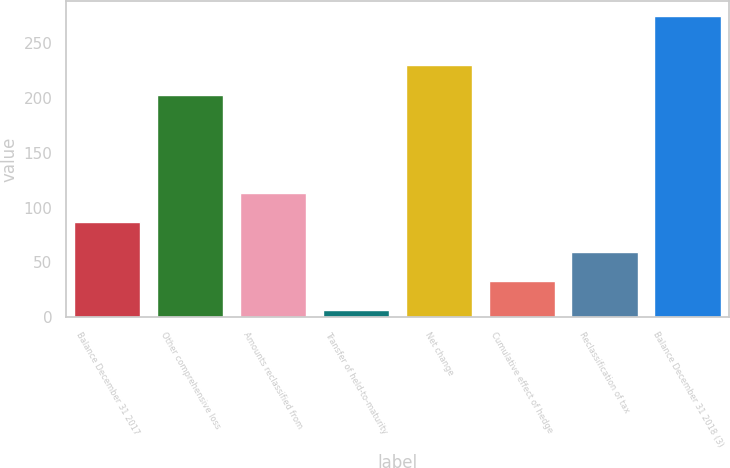Convert chart. <chart><loc_0><loc_0><loc_500><loc_500><bar_chart><fcel>Balance December 31 2017<fcel>Other comprehensive loss<fcel>Amounts reclassified from<fcel>Transfer of held-to-maturity<fcel>Net change<fcel>Cumulative effect of hedge<fcel>Reclassification of tax<fcel>Balance December 31 2018 (3)<nl><fcel>86.7<fcel>203<fcel>113.6<fcel>6<fcel>229.9<fcel>32.9<fcel>59.8<fcel>275<nl></chart> 